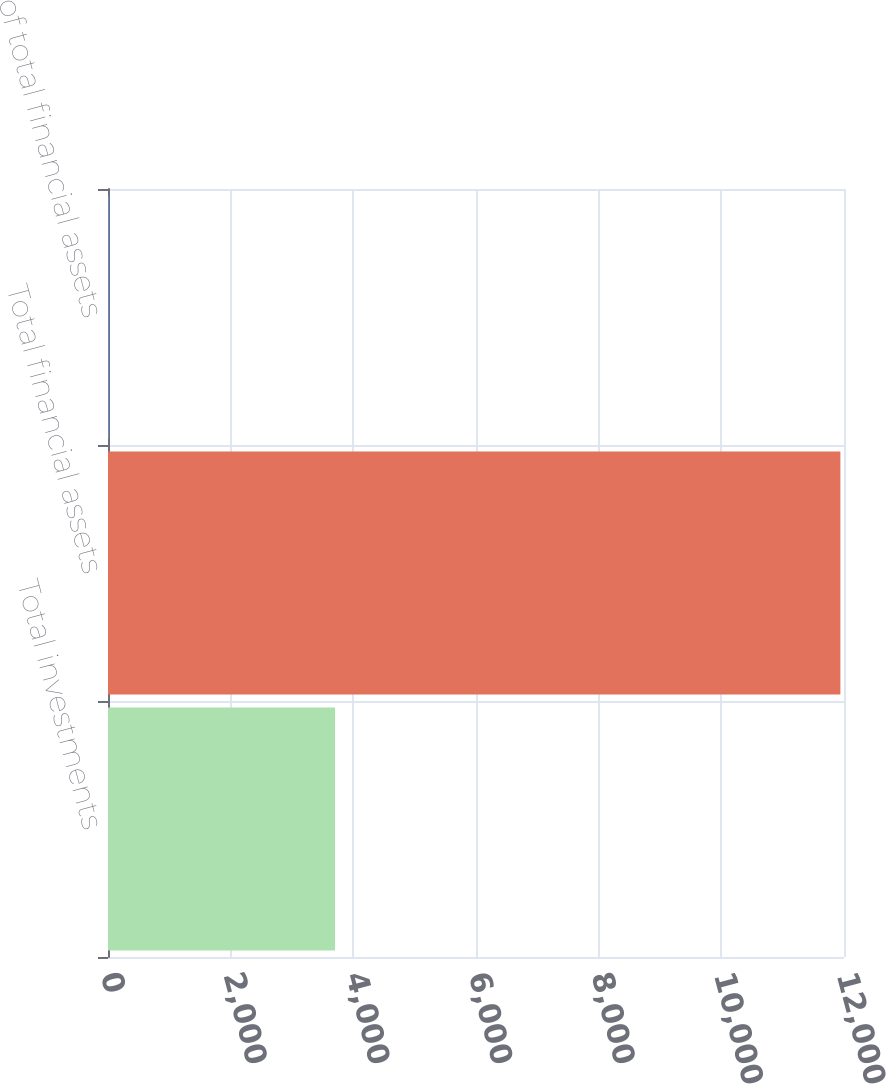Convert chart. <chart><loc_0><loc_0><loc_500><loc_500><bar_chart><fcel>Total investments<fcel>Total financial assets<fcel>of total financial assets<nl><fcel>3702<fcel>11941<fcel>11.4<nl></chart> 